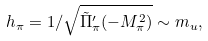Convert formula to latex. <formula><loc_0><loc_0><loc_500><loc_500>h _ { \pi } = 1 / \sqrt { \tilde { \Pi } _ { \pi } ^ { \prime } ( - M _ { \pi } ^ { 2 } ) } \sim m _ { u } ,</formula> 